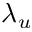<formula> <loc_0><loc_0><loc_500><loc_500>\lambda _ { u }</formula> 